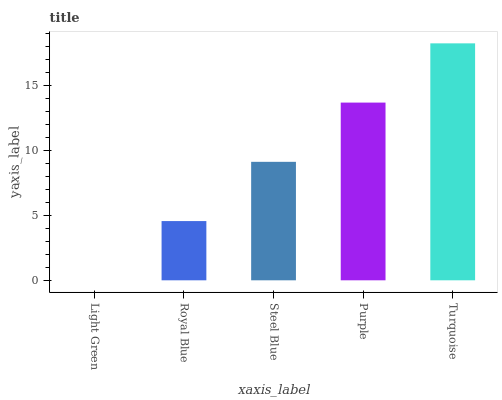Is Light Green the minimum?
Answer yes or no. Yes. Is Turquoise the maximum?
Answer yes or no. Yes. Is Royal Blue the minimum?
Answer yes or no. No. Is Royal Blue the maximum?
Answer yes or no. No. Is Royal Blue greater than Light Green?
Answer yes or no. Yes. Is Light Green less than Royal Blue?
Answer yes or no. Yes. Is Light Green greater than Royal Blue?
Answer yes or no. No. Is Royal Blue less than Light Green?
Answer yes or no. No. Is Steel Blue the high median?
Answer yes or no. Yes. Is Steel Blue the low median?
Answer yes or no. Yes. Is Turquoise the high median?
Answer yes or no. No. Is Light Green the low median?
Answer yes or no. No. 